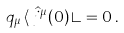<formula> <loc_0><loc_0><loc_500><loc_500>q _ { \mu } \, \langle \, \hat { j } ^ { \mu } ( 0 ) \, \rangle = 0 \, .</formula> 